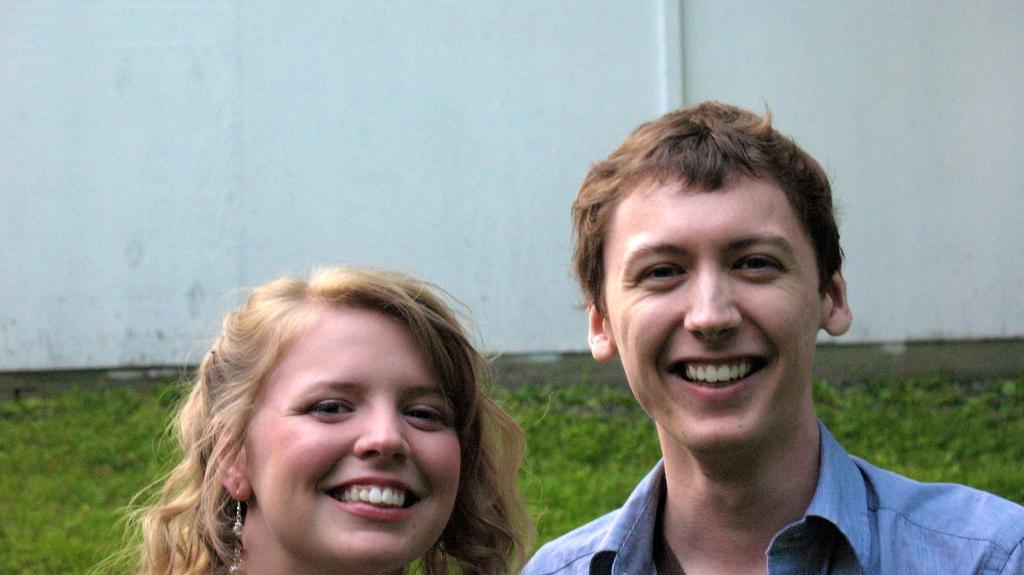Who is present in the image? There is a woman and a man in the image. What are the expressions on their faces? Both the woman and the man are smiling in the image. What are they doing in the image? The woman and the man are posing for the picture. What can be seen in the background of the image? There is a wall in the background of the image. What is the ground made of in the image? There is grass on the ground in the image. What type of silk is being woven by the ants in the image? There are no ants present in the image, and therefore no silk-weaving activity can be observed. What verse is being recited by the woman and the man in the image? There is no indication in the image that the woman and the man are reciting a verse or poem. 